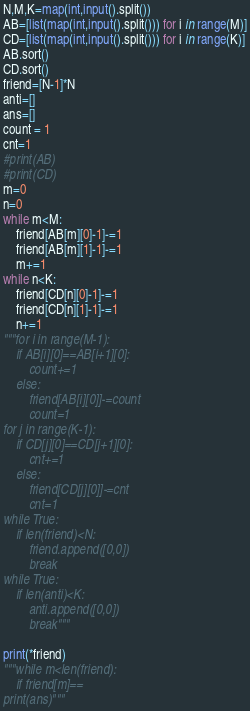<code> <loc_0><loc_0><loc_500><loc_500><_Python_>N,M,K=map(int,input().split())
AB=[list(map(int,input().split())) for i in range(M)]
CD=[list(map(int,input().split())) for i in range(K)]
AB.sort()
CD.sort()
friend=[N-1]*N
anti=[]
ans=[]
count = 1
cnt=1
#print(AB)
#print(CD)
m=0
n=0
while m<M:
    friend[AB[m][0]-1]-=1
    friend[AB[m][1]-1]-=1
    m+=1
while n<K:
    friend[CD[n][0]-1]-=1
    friend[CD[n][1]-1]-=1
    n+=1
"""for i in range(M-1):
    if AB[i][0]==AB[i+1][0]:
        count+=1
    else:
        friend[AB[i][0]]-=count
        count=1
for j in range(K-1):
    if CD[j][0]==CD[j+1][0]:
        cnt+=1
    else:
        friend[CD[j][0]]-=cnt
        cnt=1
while True:
    if len(friend)<N:
        friend.append([0,0])
        break
while True:
    if len(anti)<K:
        anti.append([0,0])
        break"""

print(*friend)
"""while m<len(friend):
    if friend[m]==
print(ans)"""</code> 